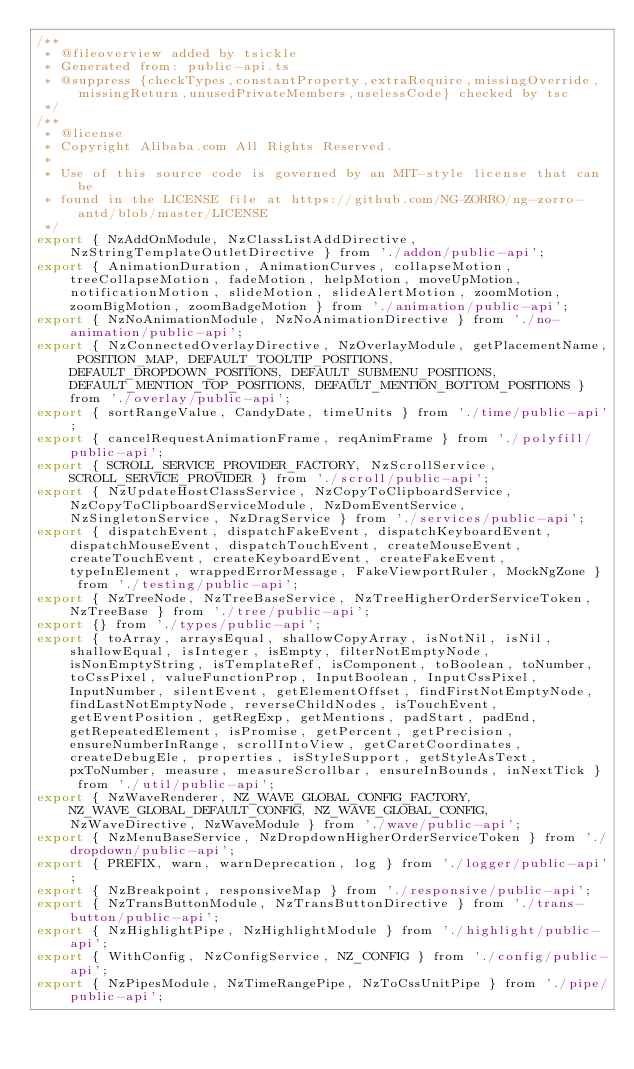Convert code to text. <code><loc_0><loc_0><loc_500><loc_500><_JavaScript_>/**
 * @fileoverview added by tsickle
 * Generated from: public-api.ts
 * @suppress {checkTypes,constantProperty,extraRequire,missingOverride,missingReturn,unusedPrivateMembers,uselessCode} checked by tsc
 */
/**
 * @license
 * Copyright Alibaba.com All Rights Reserved.
 *
 * Use of this source code is governed by an MIT-style license that can be
 * found in the LICENSE file at https://github.com/NG-ZORRO/ng-zorro-antd/blob/master/LICENSE
 */
export { NzAddOnModule, NzClassListAddDirective, NzStringTemplateOutletDirective } from './addon/public-api';
export { AnimationDuration, AnimationCurves, collapseMotion, treeCollapseMotion, fadeMotion, helpMotion, moveUpMotion, notificationMotion, slideMotion, slideAlertMotion, zoomMotion, zoomBigMotion, zoomBadgeMotion } from './animation/public-api';
export { NzNoAnimationModule, NzNoAnimationDirective } from './no-animation/public-api';
export { NzConnectedOverlayDirective, NzOverlayModule, getPlacementName, POSITION_MAP, DEFAULT_TOOLTIP_POSITIONS, DEFAULT_DROPDOWN_POSITIONS, DEFAULT_SUBMENU_POSITIONS, DEFAULT_MENTION_TOP_POSITIONS, DEFAULT_MENTION_BOTTOM_POSITIONS } from './overlay/public-api';
export { sortRangeValue, CandyDate, timeUnits } from './time/public-api';
export { cancelRequestAnimationFrame, reqAnimFrame } from './polyfill/public-api';
export { SCROLL_SERVICE_PROVIDER_FACTORY, NzScrollService, SCROLL_SERVICE_PROVIDER } from './scroll/public-api';
export { NzUpdateHostClassService, NzCopyToClipboardService, NzCopyToClipboardServiceModule, NzDomEventService, NzSingletonService, NzDragService } from './services/public-api';
export { dispatchEvent, dispatchFakeEvent, dispatchKeyboardEvent, dispatchMouseEvent, dispatchTouchEvent, createMouseEvent, createTouchEvent, createKeyboardEvent, createFakeEvent, typeInElement, wrappedErrorMessage, FakeViewportRuler, MockNgZone } from './testing/public-api';
export { NzTreeNode, NzTreeBaseService, NzTreeHigherOrderServiceToken, NzTreeBase } from './tree/public-api';
export {} from './types/public-api';
export { toArray, arraysEqual, shallowCopyArray, isNotNil, isNil, shallowEqual, isInteger, isEmpty, filterNotEmptyNode, isNonEmptyString, isTemplateRef, isComponent, toBoolean, toNumber, toCssPixel, valueFunctionProp, InputBoolean, InputCssPixel, InputNumber, silentEvent, getElementOffset, findFirstNotEmptyNode, findLastNotEmptyNode, reverseChildNodes, isTouchEvent, getEventPosition, getRegExp, getMentions, padStart, padEnd, getRepeatedElement, isPromise, getPercent, getPrecision, ensureNumberInRange, scrollIntoView, getCaretCoordinates, createDebugEle, properties, isStyleSupport, getStyleAsText, pxToNumber, measure, measureScrollbar, ensureInBounds, inNextTick } from './util/public-api';
export { NzWaveRenderer, NZ_WAVE_GLOBAL_CONFIG_FACTORY, NZ_WAVE_GLOBAL_DEFAULT_CONFIG, NZ_WAVE_GLOBAL_CONFIG, NzWaveDirective, NzWaveModule } from './wave/public-api';
export { NzMenuBaseService, NzDropdownHigherOrderServiceToken } from './dropdown/public-api';
export { PREFIX, warn, warnDeprecation, log } from './logger/public-api';
export { NzBreakpoint, responsiveMap } from './responsive/public-api';
export { NzTransButtonModule, NzTransButtonDirective } from './trans-button/public-api';
export { NzHighlightPipe, NzHighlightModule } from './highlight/public-api';
export { WithConfig, NzConfigService, NZ_CONFIG } from './config/public-api';
export { NzPipesModule, NzTimeRangePipe, NzToCssUnitPipe } from './pipe/public-api';</code> 